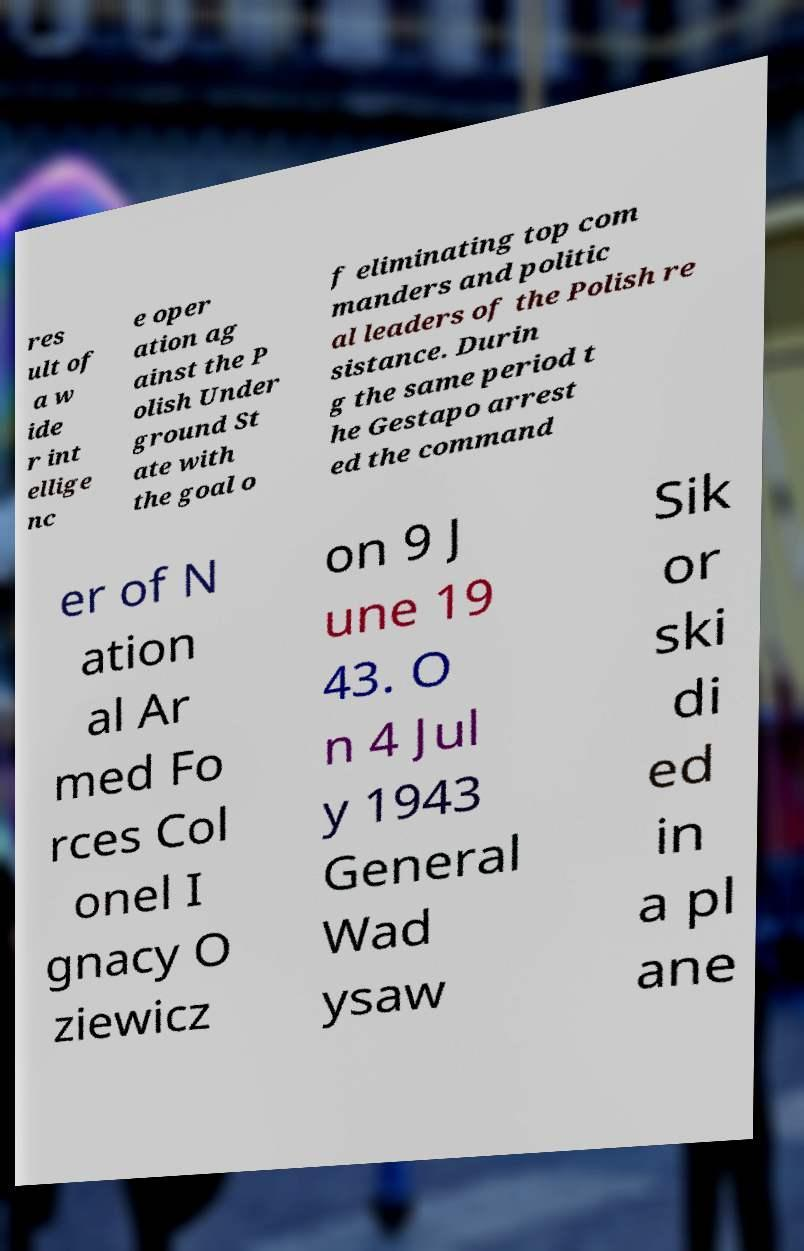There's text embedded in this image that I need extracted. Can you transcribe it verbatim? res ult of a w ide r int ellige nc e oper ation ag ainst the P olish Under ground St ate with the goal o f eliminating top com manders and politic al leaders of the Polish re sistance. Durin g the same period t he Gestapo arrest ed the command er of N ation al Ar med Fo rces Col onel I gnacy O ziewicz on 9 J une 19 43. O n 4 Jul y 1943 General Wad ysaw Sik or ski di ed in a pl ane 